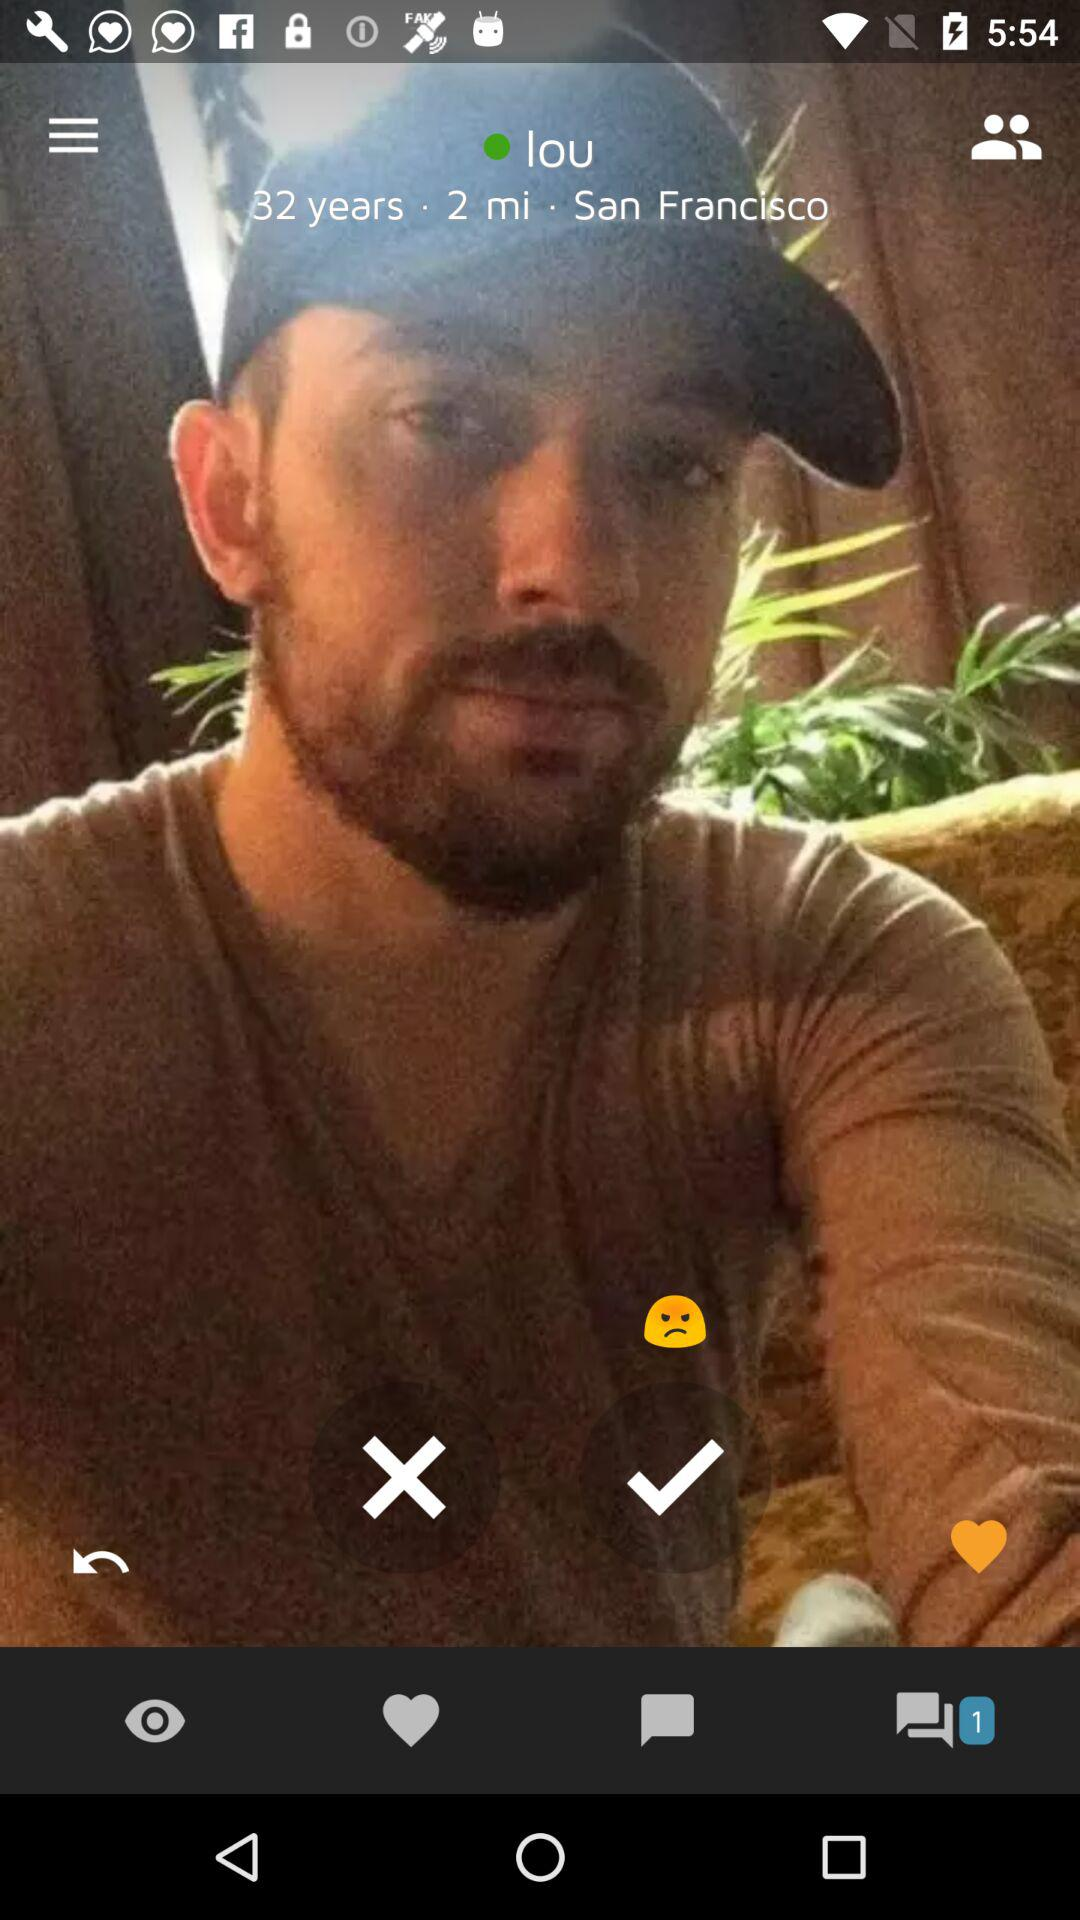What is the location given on the screen? The location is San Francisco. 